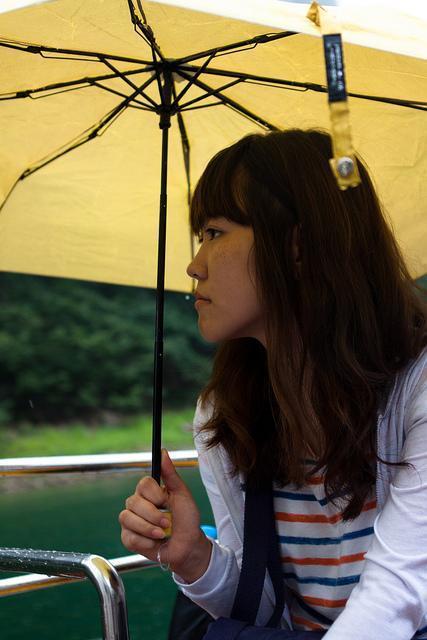Does the caption "The umbrella is close to the person." correctly depict the image?
Answer yes or no. Yes. 